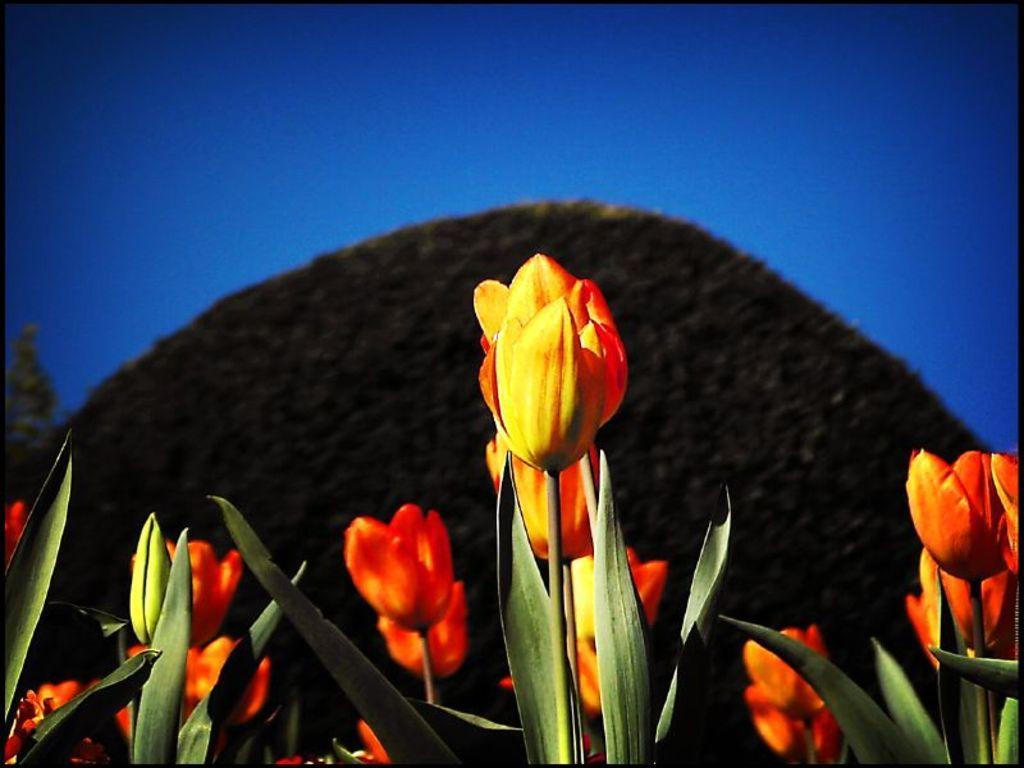How would you summarize this image in a sentence or two? In the picture we can see some flowers which are in red and yellow in color and in the background we can see blue color view. 